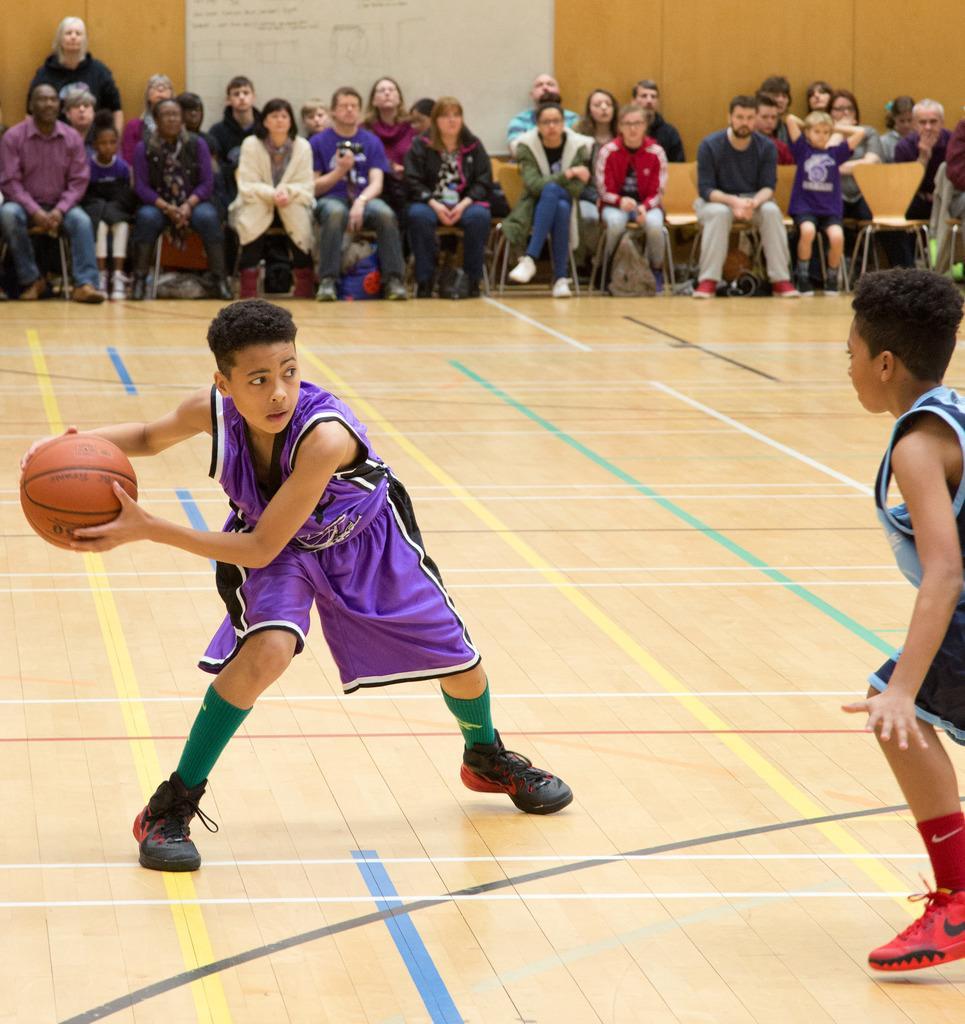In one or two sentences, can you explain what this image depicts? In this picture we can see there are two kids standing on the path and a boy is holding a ball. Behind the kids there are some people sitting on chairs and a person is standing. Behind the people there is a wooden wall and a white board. 